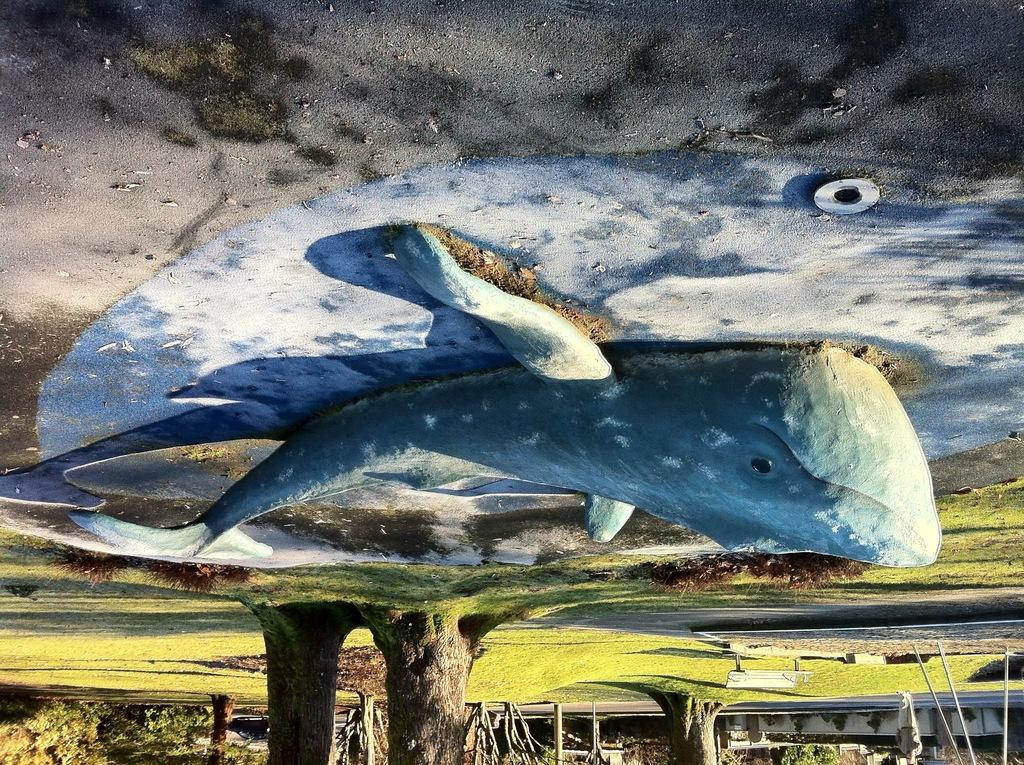What is the main subject of the image? There is a statue of a fish in the image. Where is the statue located? The statue is on the floor. What type of natural environment is visible in the image? There are trees and grass in the image. What type of grape is being used to write in the notebook in the image? There is no notebook or grape present in the image. What historical event is depicted in the image? The image does not depict any historical event; it features a statue of a fish on the floor with trees and grass in the background. 